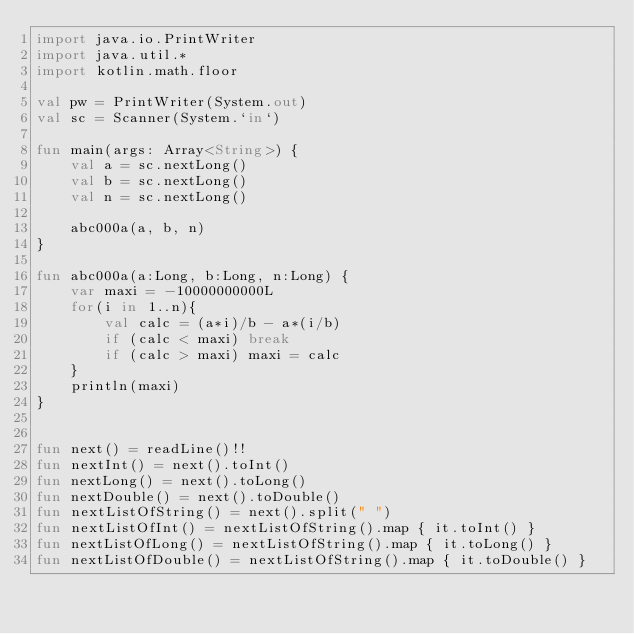Convert code to text. <code><loc_0><loc_0><loc_500><loc_500><_Kotlin_>import java.io.PrintWriter
import java.util.*
import kotlin.math.floor

val pw = PrintWriter(System.out)
val sc = Scanner(System.`in`)

fun main(args: Array<String>) {
    val a = sc.nextLong()
    val b = sc.nextLong()
    val n = sc.nextLong()

    abc000a(a, b, n)
}

fun abc000a(a:Long, b:Long, n:Long) {
    var maxi = -10000000000L
    for(i in 1..n){
        val calc = (a*i)/b - a*(i/b)
        if (calc < maxi) break
        if (calc > maxi) maxi = calc
    }
    println(maxi)
}


fun next() = readLine()!!
fun nextInt() = next().toInt()
fun nextLong() = next().toLong()
fun nextDouble() = next().toDouble()
fun nextListOfString() = next().split(" ")
fun nextListOfInt() = nextListOfString().map { it.toInt() }
fun nextListOfLong() = nextListOfString().map { it.toLong() }
fun nextListOfDouble() = nextListOfString().map { it.toDouble() }

</code> 